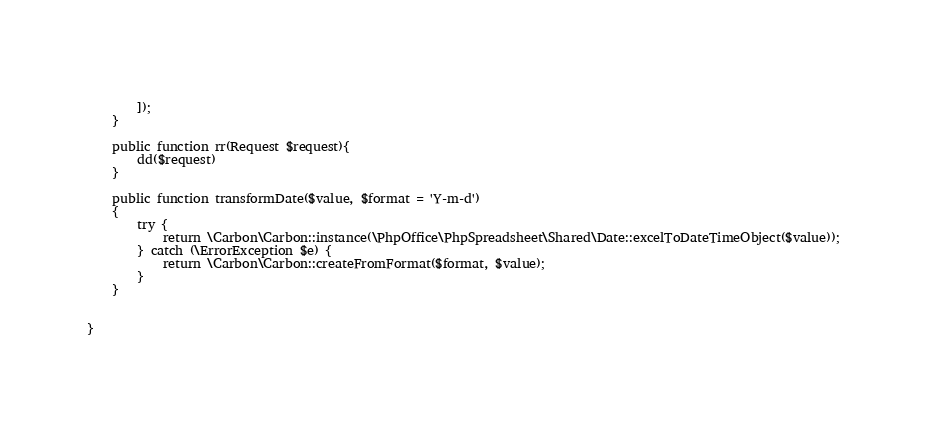<code> <loc_0><loc_0><loc_500><loc_500><_PHP_>           
        ]);
    }

    public function rr(Request $request){
        dd($request)
    }

    public function transformDate($value, $format = 'Y-m-d')
    {
        try {
            return \Carbon\Carbon::instance(\PhpOffice\PhpSpreadsheet\Shared\Date::excelToDateTimeObject($value));
        } catch (\ErrorException $e) {
            return \Carbon\Carbon::createFromFormat($format, $value);
        }
    }

    
}
</code> 